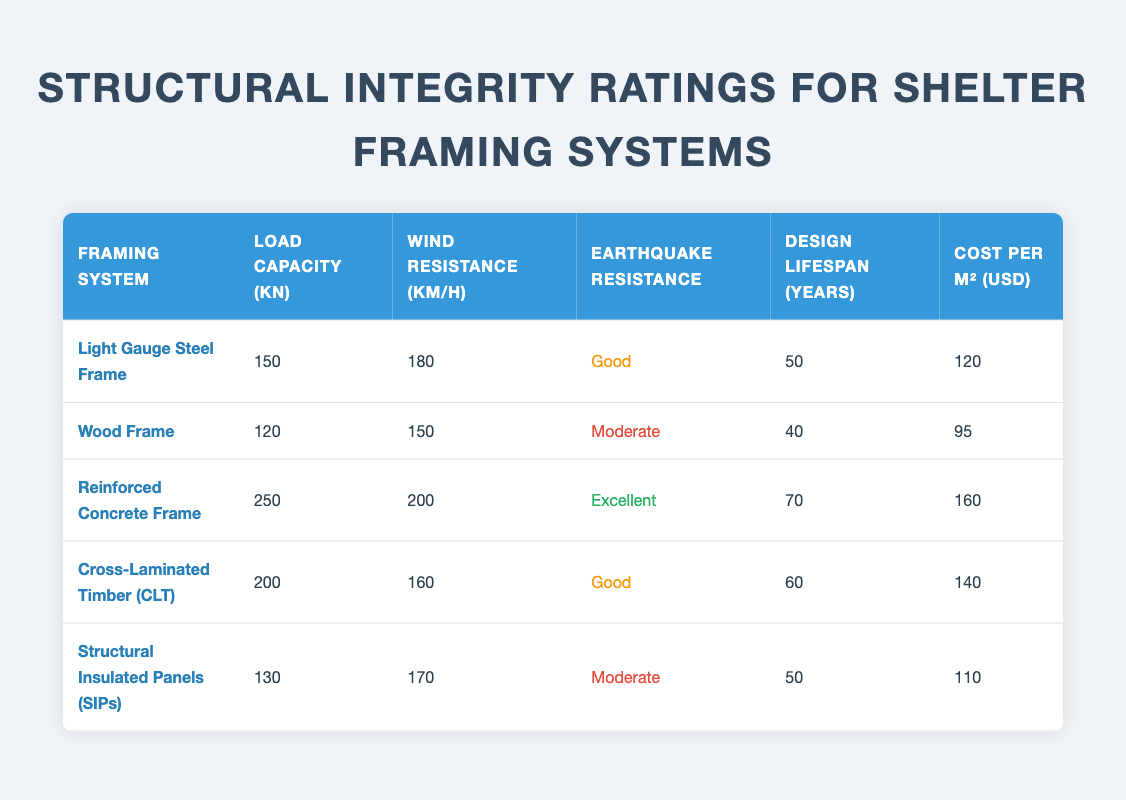What is the load capacity of the Reinforced Concrete Frame? The load capacity of the Reinforced Concrete Frame can be found directly in the corresponding row under the 'Load Capacity (kN)' column. The value listed for this framing system is 250 kN.
Answer: 250 kN Which framing system has the highest wind resistance? To find the highest wind resistance, we compare the 'Wind Resistance (km/h)' values in the table. The Reinforced Concrete Frame has the highest value at 200 km/h.
Answer: Reinforced Concrete Frame What is the difference in cost per square meter between the Wood Frame and the Cross-Laminated Timber (CLT)? First, we identify the costs for both systems: Wood Frame is 95 USD/m², and Cross-Laminated Timber (CLT) is 140 USD/m². Then, we calculate the difference: 140 - 95 = 45.
Answer: 45 USD Is the Structural Insulated Panels (SIPs) earthquake resistance rating good? In the table, the earthquake resistance rating for Structural Insulated Panels (SIPs) is listed as "Moderate." Therefore, the answer is no; it is not rated as good.
Answer: No What is the average design lifespan of all the framing systems listed? To find the average lifespan, we add all the 'Design Lifespan (years)' values together: 50 + 40 + 70 + 60 + 50 = 270 years. Then, we divide by the number of systems (5): 270 / 5 = 54.
Answer: 54 years Which framing system has both the lowest cost per square meter and the lowest load capacity? The Wood Frame has the lowest cost per square meter at 95 USD/m² and a load capacity of 120 kN. After evaluating all rows, no other system meets both criteria.
Answer: Wood Frame How many framing systems have an earthquake resistance rating classified as "Good"? When examining the table, the Light Gauge Steel Frame and Cross-Laminated Timber (CLT) both have a "Good" rating for earthquake resistance. Thus, we find there are 2 systems.
Answer: 2 systems What is the combined load capacity of the Light Gauge Steel Frame and Structural Insulated Panels (SIPs)? The load capacity of the Light Gauge Steel Frame is 150 kN, and for SIPs, it is 130 kN. By adding these two values together: 150 + 130, we get 280 kN.
Answer: 280 kN Is the Wood Frame the most economical option based on cost per square meter? The cost of the Wood Frame is 95 USD/m². By comparing it with other framing systems, we see that no system is cheaper than this, thus it is indeed the most economical option.
Answer: Yes 